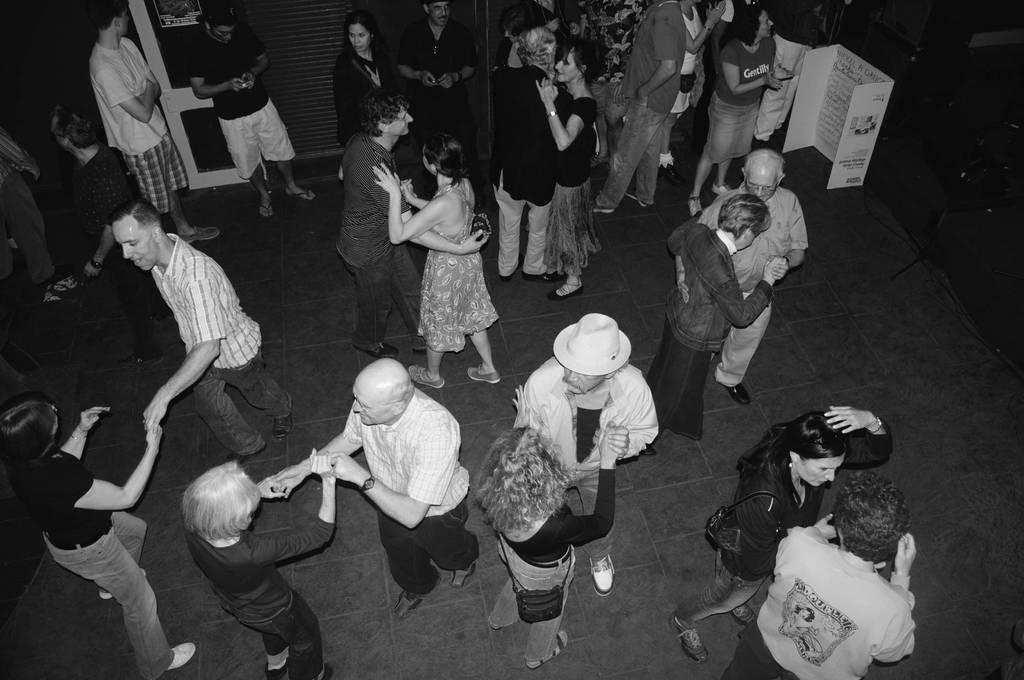What is the color scheme of the image? The image is black and white. What are the people in the image doing? There is a group of people dancing on the floor. Are there any people standing in the image? Yes, some people are standing in the image. What can be seen behind the people in the image? There is a wall visible behind the people. What type of stew is being served to the people in the image? There is no stew present in the image; it features a group of people dancing and standing. Can you tell me how many engines are visible in the image? There are no engines present in the image. 